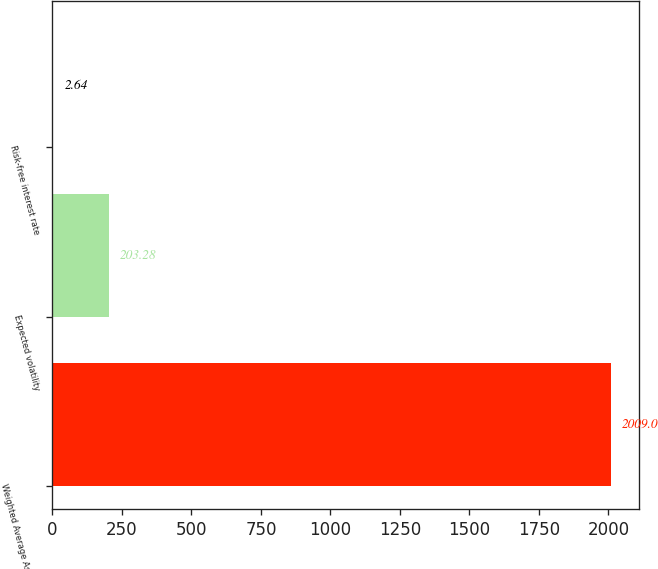<chart> <loc_0><loc_0><loc_500><loc_500><bar_chart><fcel>Weighted Average Assumption<fcel>Expected volatility<fcel>Risk-free interest rate<nl><fcel>2009<fcel>203.28<fcel>2.64<nl></chart> 